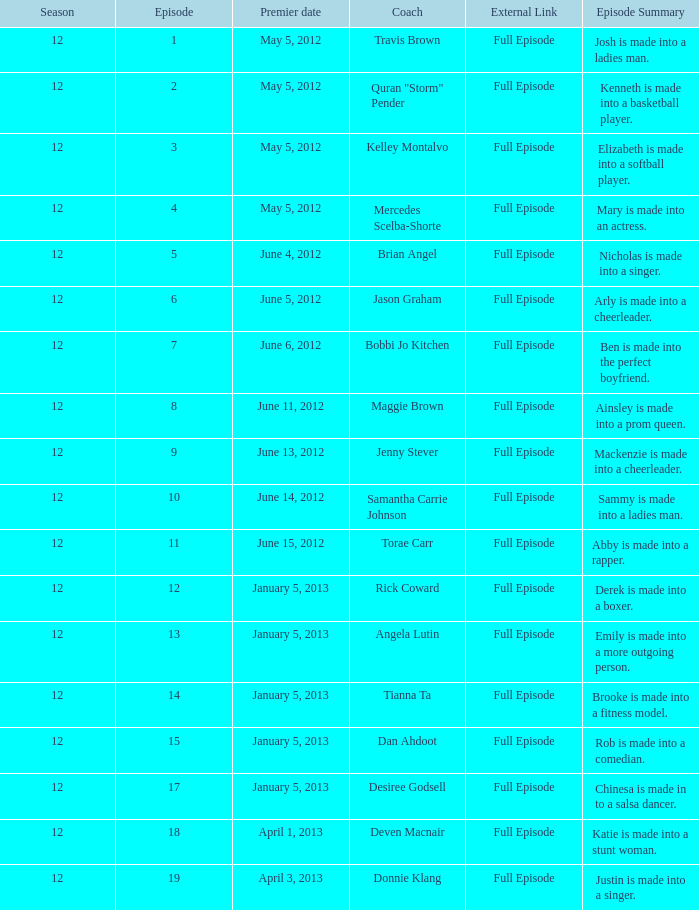Name the coach for  emily is made into a more outgoing person. Angela Lutin. 